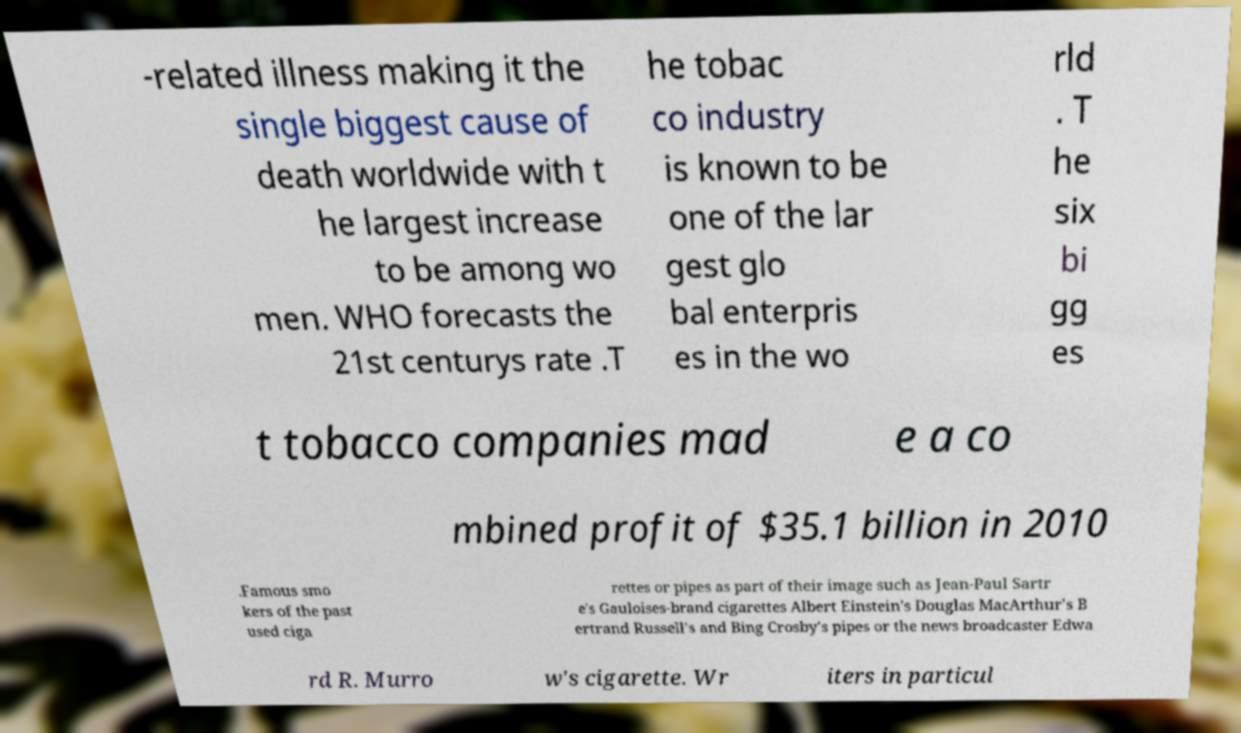Could you assist in decoding the text presented in this image and type it out clearly? -related illness making it the single biggest cause of death worldwide with t he largest increase to be among wo men. WHO forecasts the 21st centurys rate .T he tobac co industry is known to be one of the lar gest glo bal enterpris es in the wo rld . T he six bi gg es t tobacco companies mad e a co mbined profit of $35.1 billion in 2010 .Famous smo kers of the past used ciga rettes or pipes as part of their image such as Jean-Paul Sartr e's Gauloises-brand cigarettes Albert Einstein's Douglas MacArthur's B ertrand Russell's and Bing Crosby's pipes or the news broadcaster Edwa rd R. Murro w's cigarette. Wr iters in particul 